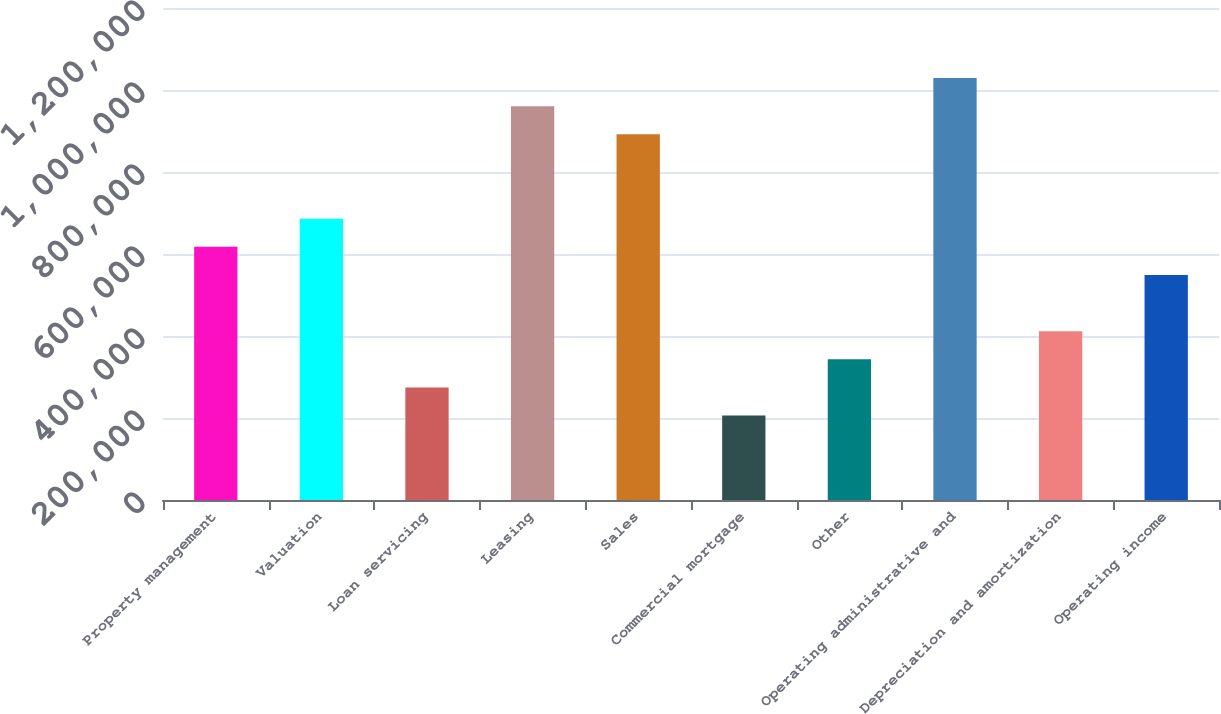Convert chart to OTSL. <chart><loc_0><loc_0><loc_500><loc_500><bar_chart><fcel>Property management<fcel>Valuation<fcel>Loan servicing<fcel>Leasing<fcel>Sales<fcel>Commercial mortgage<fcel>Other<fcel>Operating administrative and<fcel>Depreciation and amortization<fcel>Operating income<nl><fcel>617473<fcel>686079<fcel>274445<fcel>960502<fcel>891896<fcel>205839<fcel>343050<fcel>1.02911e+06<fcel>411656<fcel>548868<nl></chart> 